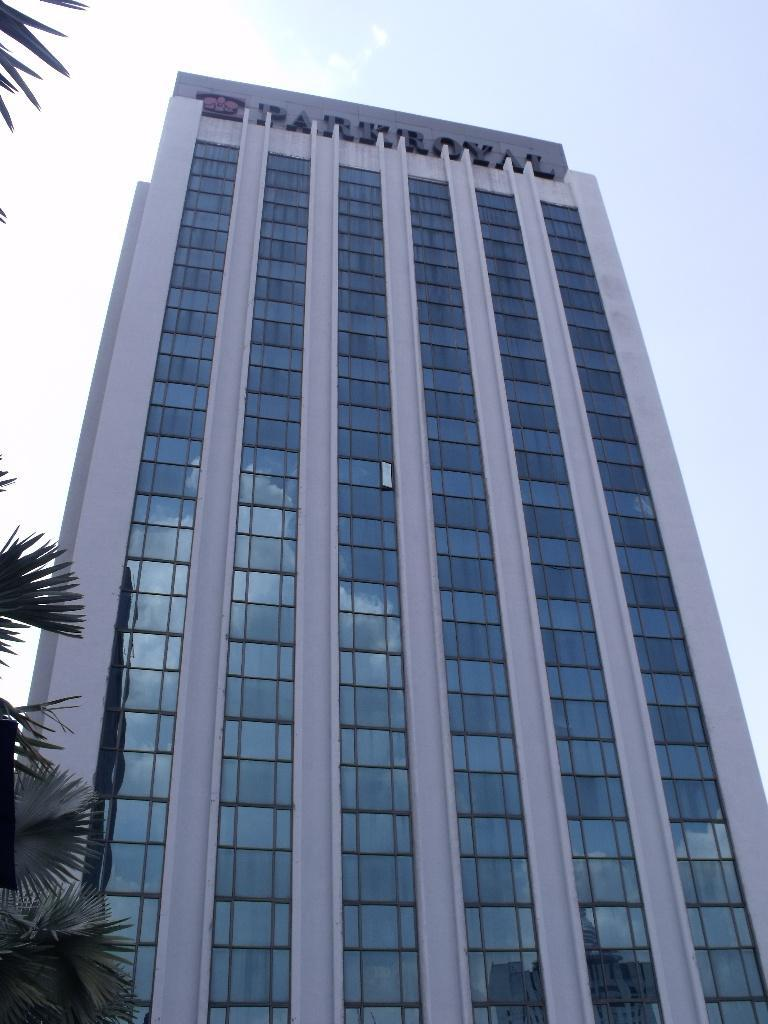What is the main subject of the image? The main subject of the image is a building with a name. What can be seen on the left side of the image? There are leaves on the left side of the image. What is visible in the sky at the top of the image? There are clouds in the sky at the top of the image. What type of harmony is being played by the lawyer in the image? There is no lawyer or harmony present in the image. 